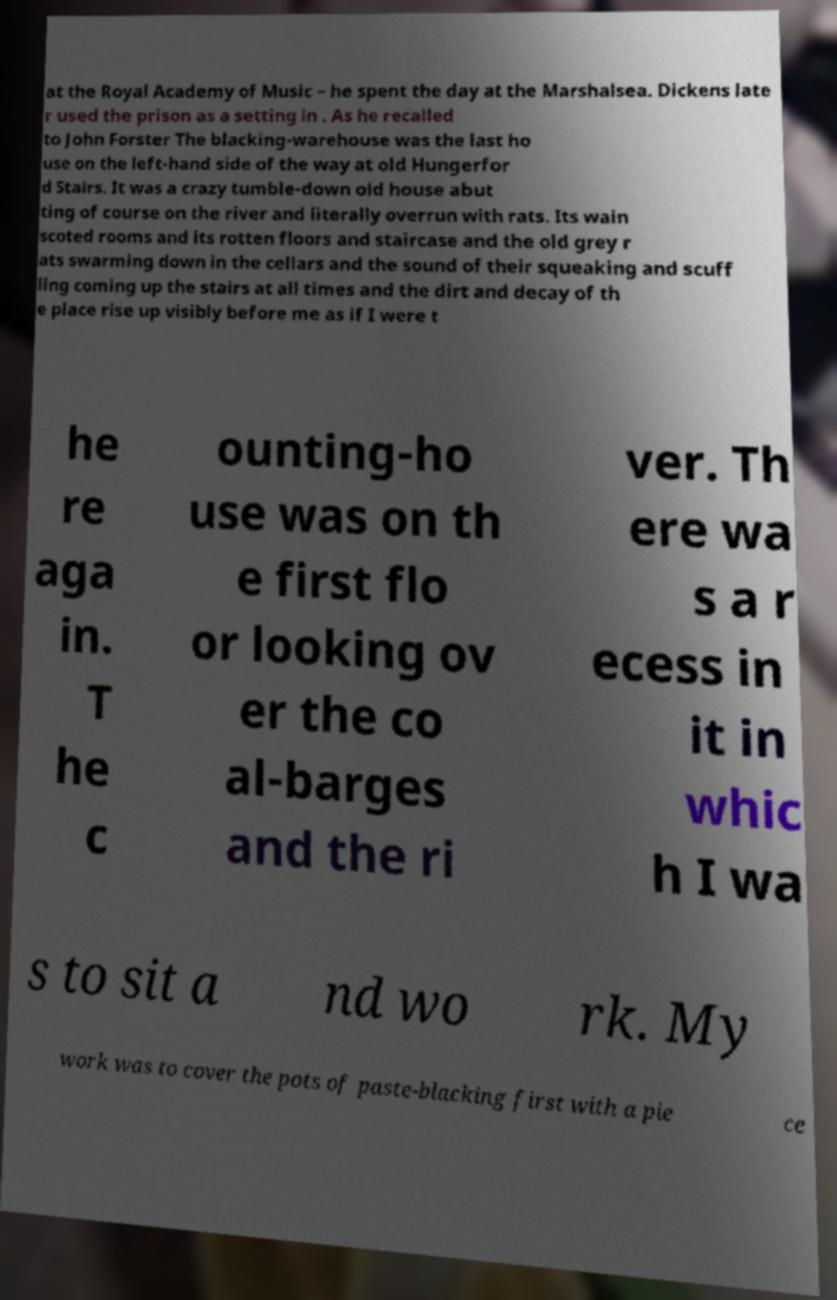Please read and relay the text visible in this image. What does it say? at the Royal Academy of Music – he spent the day at the Marshalsea. Dickens late r used the prison as a setting in . As he recalled to John Forster The blacking-warehouse was the last ho use on the left-hand side of the way at old Hungerfor d Stairs. It was a crazy tumble-down old house abut ting of course on the river and literally overrun with rats. Its wain scoted rooms and its rotten floors and staircase and the old grey r ats swarming down in the cellars and the sound of their squeaking and scuff ling coming up the stairs at all times and the dirt and decay of th e place rise up visibly before me as if I were t he re aga in. T he c ounting-ho use was on th e first flo or looking ov er the co al-barges and the ri ver. Th ere wa s a r ecess in it in whic h I wa s to sit a nd wo rk. My work was to cover the pots of paste-blacking first with a pie ce 